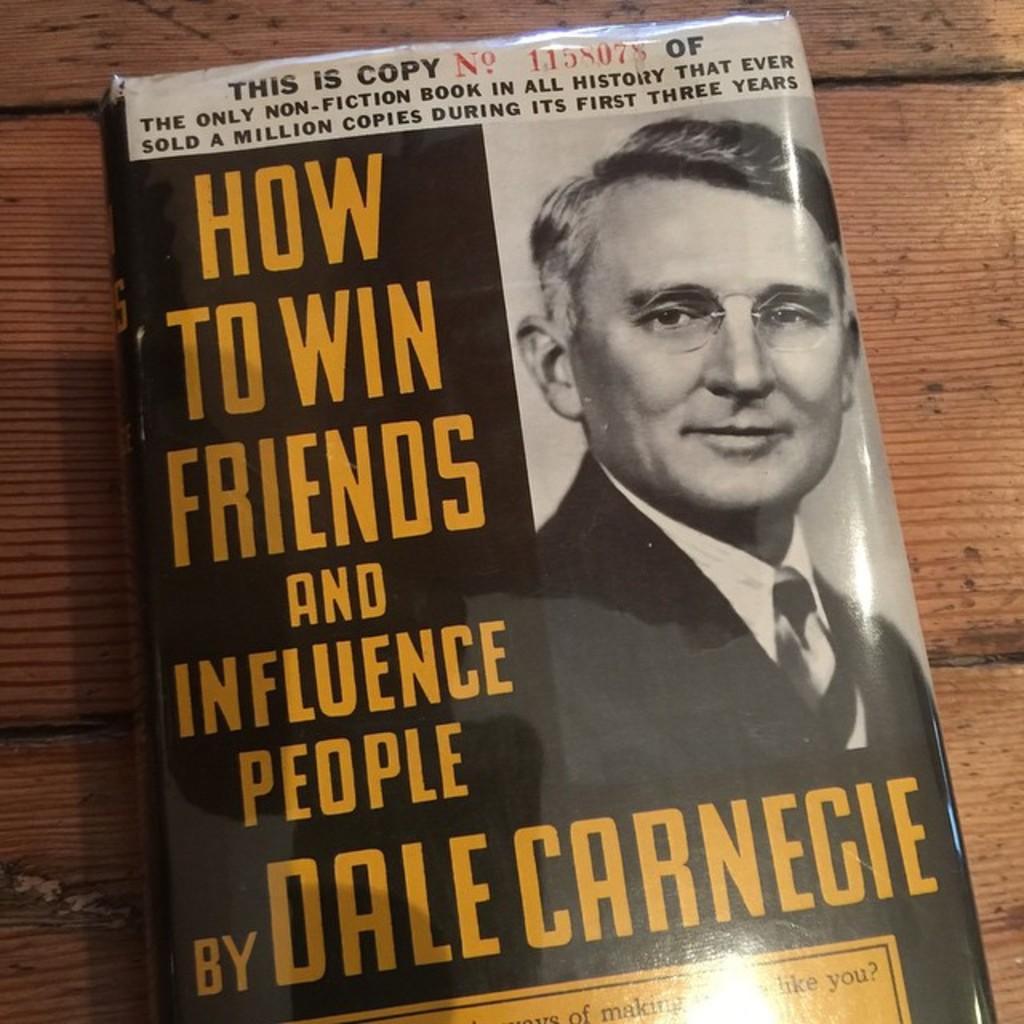Describe this image in one or two sentences. In this image I can see a book on a wooden surface. There is an image and some matter written on the cover page of the book. 